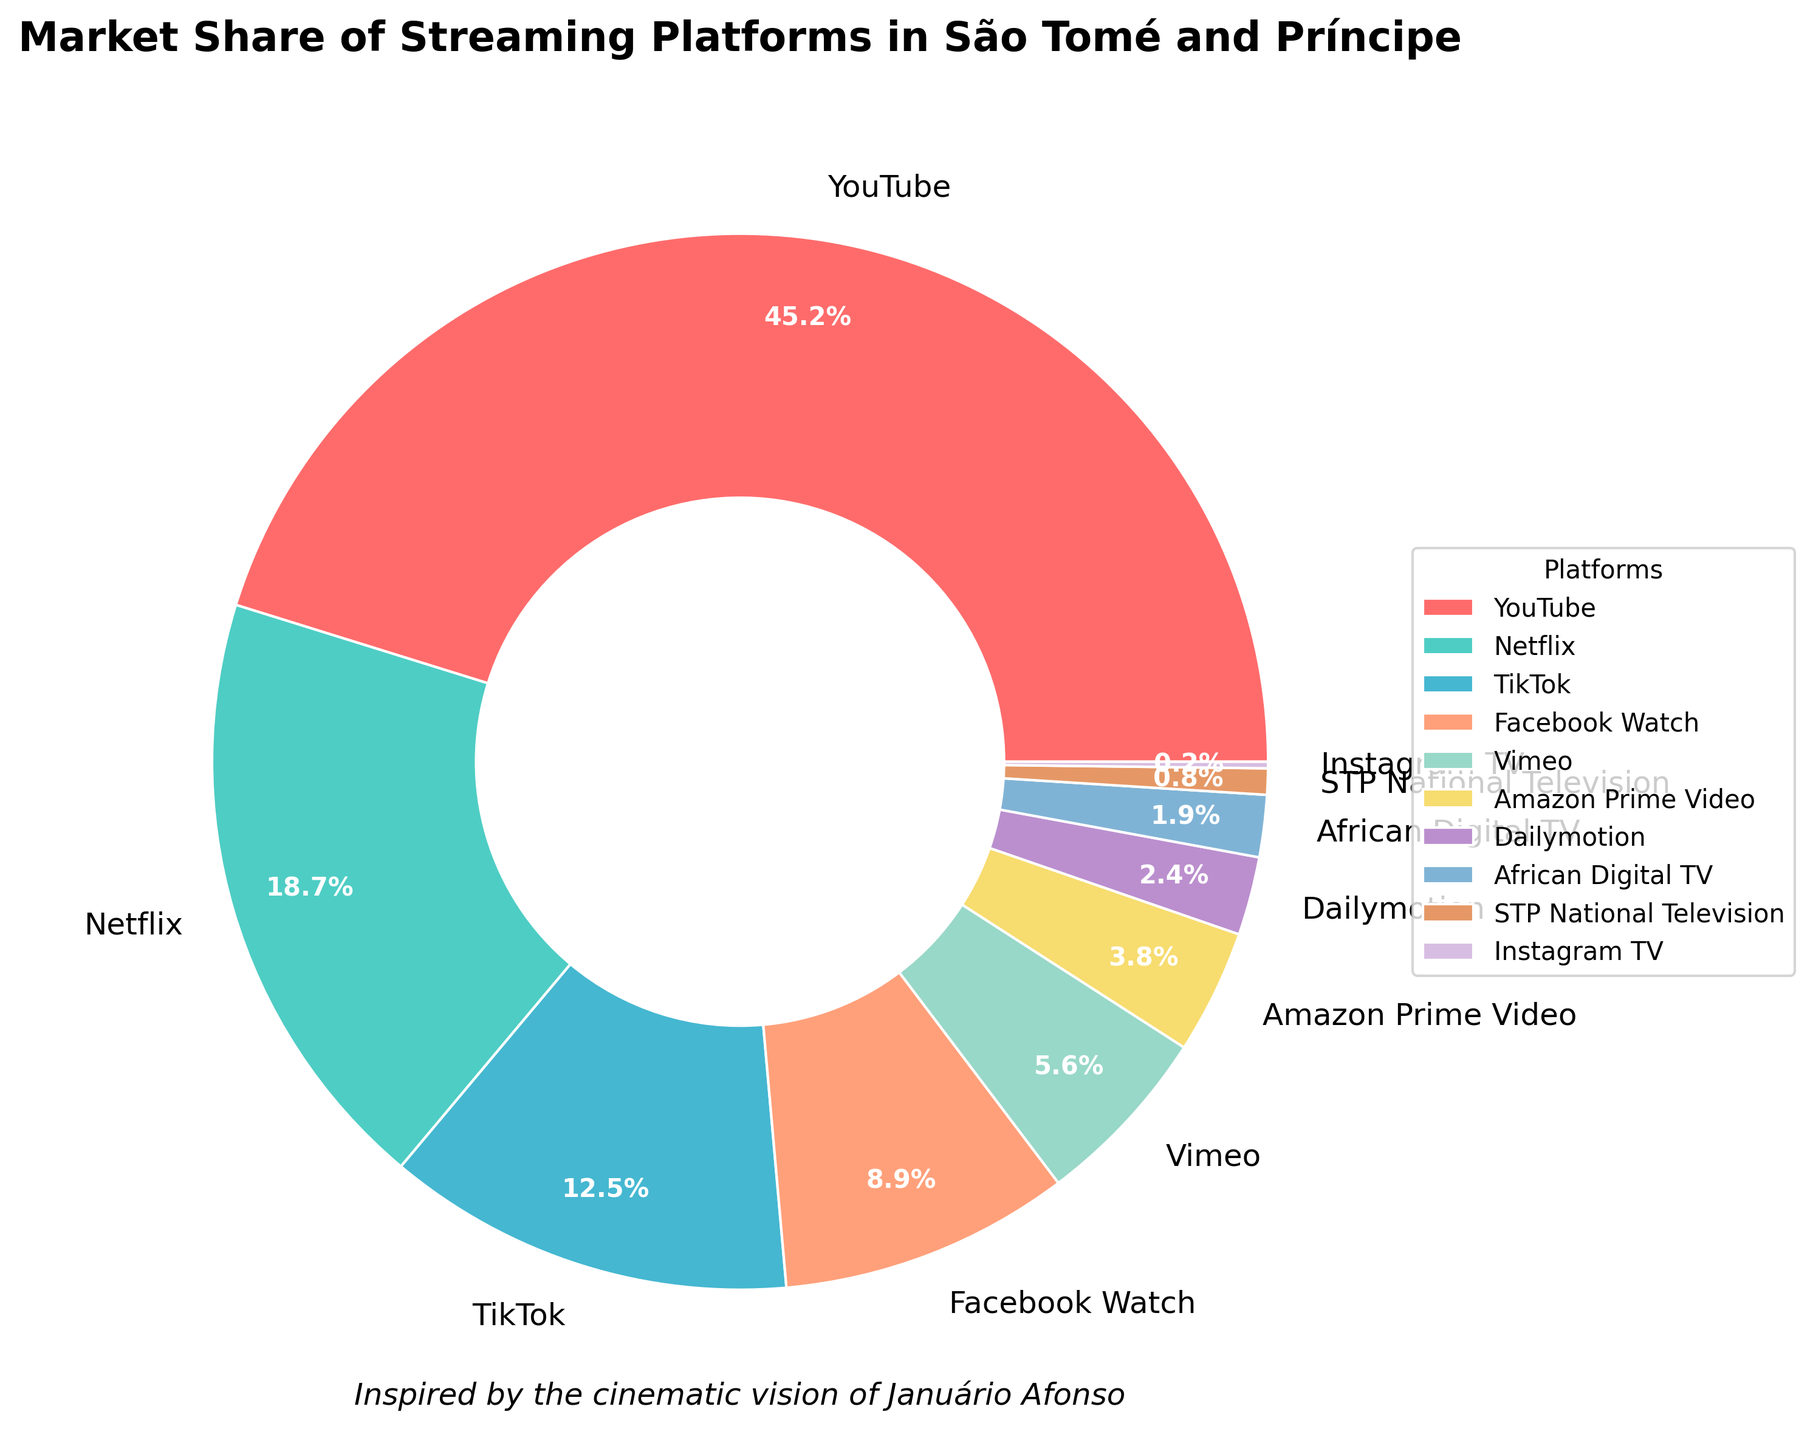Which streaming platform has the largest market share in São Tomé and Príncipe? According to the pie chart, YouTube has the largest section, indicating the highest market share among the streaming platforms presented.
Answer: YouTube What is the percentage difference in market share between YouTube and Netflix? The pie chart shows the market share of YouTube as 45.2% and Netflix as 18.7%. Subtract Netflix's market share from YouTube's: 45.2% - 18.7% = 26.5%.
Answer: 26.5% How many platforms have a market share less than 5%? By examining the pie chart, the platforms with less than 5% market share are Amazon Prime Video, Dailymotion, African Digital TV, STP National Television, and Instagram TV. Counting these up gives a total of 5 platforms.
Answer: 5 What is the combined market share of TikTok and Facebook Watch? The pie chart indicates TikTok has a market share of 12.5% and Facebook Watch has 8.9%. Adding these together results in 12.5% + 8.9% = 21.4%.
Answer: 21.4% Which platform has a higher market share, Vimeo or Amazon Prime Video, and by how much? According to the pie chart, Vimeo has a market share of 5.6% and Amazon Prime Video has 3.8%. Subtracting Amazon's share from Vimeo's: 5.6% - 3.8% = 1.8%.
Answer: Vimeo by 1.8% List the platforms with a market share between 0.5% and 5%, inclusive. The pie chart shows that STP National Television (0.8%), African Digital TV (1.9%), Dailymotion (2.4%), and Amazon Prime Video (3.8%) fall within the 0.5% to 5% range.
Answer: STP National Television, African Digital TV, Dailymotion, Amazon Prime Video What is the total market share held by the least three popular platforms? From the pie chart, the three platforms with the smallest market shares are STP National Television (0.8%), Instagram TV (0.2%), and African Digital TV (1.9%). Adding these together: 0.8% + 0.2% + 1.9% = 2.9%.
Answer: 2.9% Which platforms' market shares, when combined, are equal to or greater than Netflix's market share (18.7%) but less than YouTube’s market share (45.2%)? The pie chart shows TikTok has 12.5% and Facebook Watch has 8.9%. Together, they sum to 12.5% + 8.9% = 21.4%. This is more than Netflix’s 18.7% but less than YouTube’s 45.2%.
Answer: TikTok and Facebook Watch 